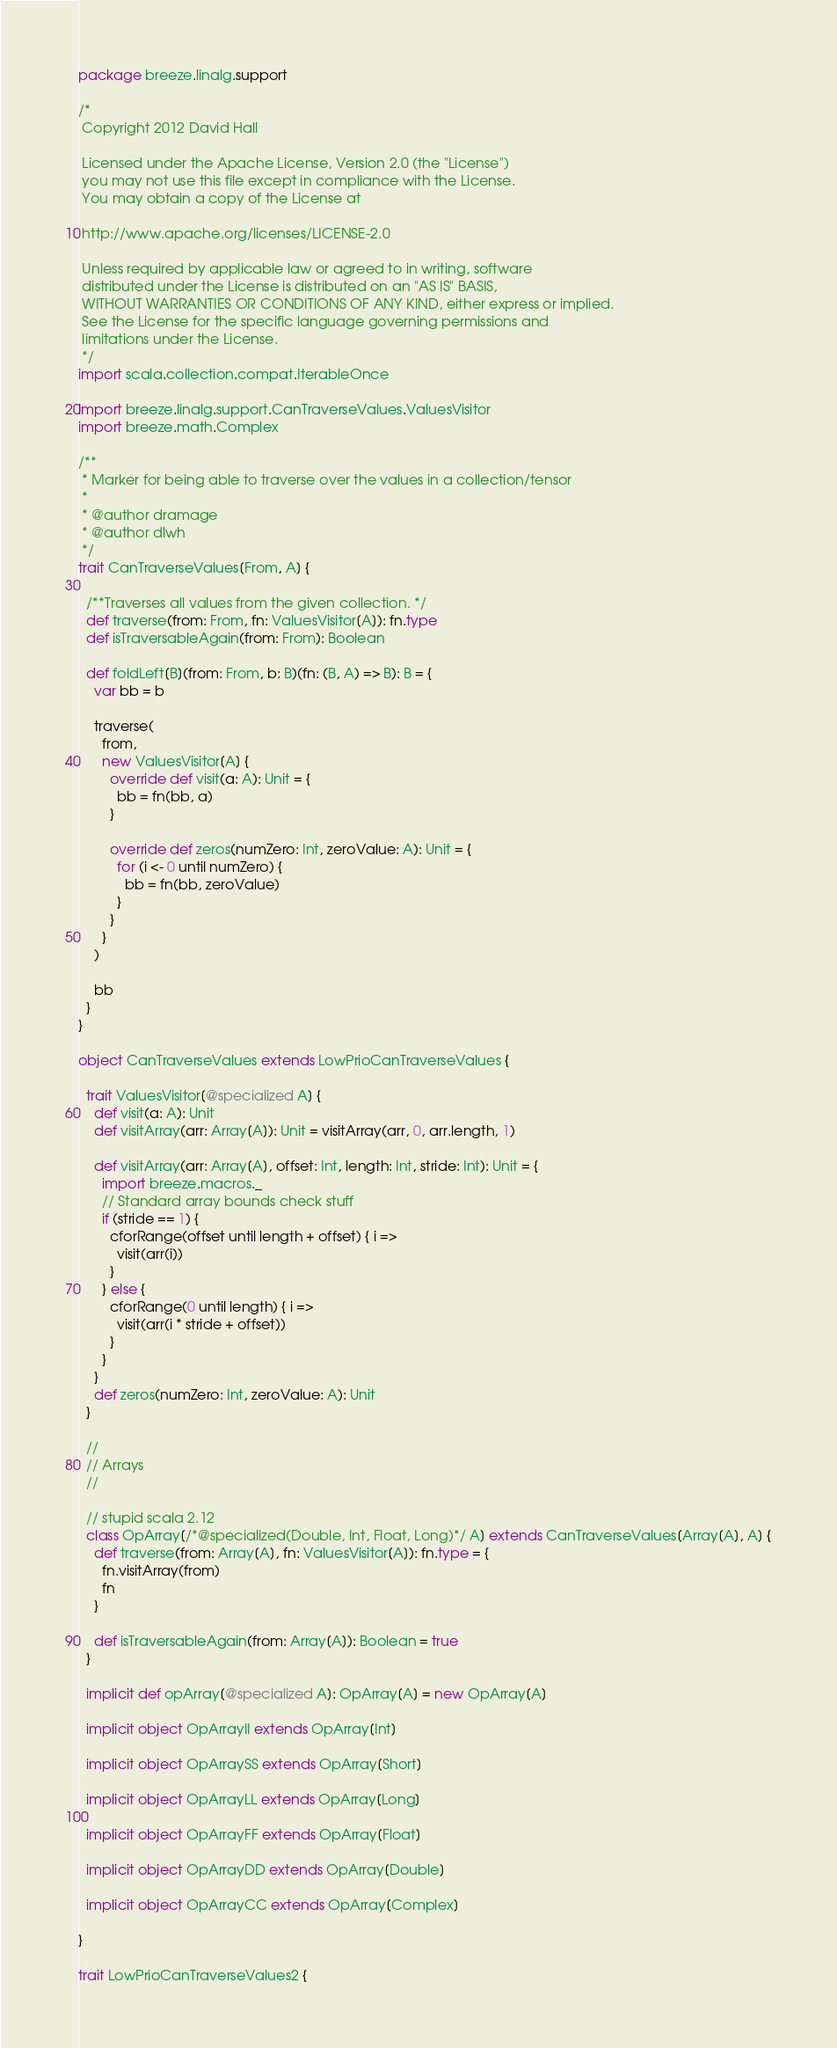Convert code to text. <code><loc_0><loc_0><loc_500><loc_500><_Scala_>package breeze.linalg.support

/*
 Copyright 2012 David Hall

 Licensed under the Apache License, Version 2.0 (the "License")
 you may not use this file except in compliance with the License.
 You may obtain a copy of the License at

 http://www.apache.org/licenses/LICENSE-2.0

 Unless required by applicable law or agreed to in writing, software
 distributed under the License is distributed on an "AS IS" BASIS,
 WITHOUT WARRANTIES OR CONDITIONS OF ANY KIND, either express or implied.
 See the License for the specific language governing permissions and
 limitations under the License.
 */
import scala.collection.compat.IterableOnce

import breeze.linalg.support.CanTraverseValues.ValuesVisitor
import breeze.math.Complex

/**
 * Marker for being able to traverse over the values in a collection/tensor
 *
 * @author dramage
 * @author dlwh
 */
trait CanTraverseValues[From, A] {

  /**Traverses all values from the given collection. */
  def traverse(from: From, fn: ValuesVisitor[A]): fn.type
  def isTraversableAgain(from: From): Boolean

  def foldLeft[B](from: From, b: B)(fn: (B, A) => B): B = {
    var bb = b

    traverse(
      from,
      new ValuesVisitor[A] {
        override def visit(a: A): Unit = {
          bb = fn(bb, a)
        }

        override def zeros(numZero: Int, zeroValue: A): Unit = {
          for (i <- 0 until numZero) {
            bb = fn(bb, zeroValue)
          }
        }
      }
    )

    bb
  }
}

object CanTraverseValues extends LowPrioCanTraverseValues {

  trait ValuesVisitor[@specialized A] {
    def visit(a: A): Unit
    def visitArray(arr: Array[A]): Unit = visitArray(arr, 0, arr.length, 1)

    def visitArray(arr: Array[A], offset: Int, length: Int, stride: Int): Unit = {
      import breeze.macros._
      // Standard array bounds check stuff
      if (stride == 1) {
        cforRange(offset until length + offset) { i =>
          visit(arr(i))
        }
      } else {
        cforRange(0 until length) { i =>
          visit(arr(i * stride + offset))
        }
      }
    }
    def zeros(numZero: Int, zeroValue: A): Unit
  }

  //
  // Arrays
  //

  // stupid scala 2.12
  class OpArray[/*@specialized(Double, Int, Float, Long)*/ A] extends CanTraverseValues[Array[A], A] {
    def traverse(from: Array[A], fn: ValuesVisitor[A]): fn.type = {
      fn.visitArray(from)
      fn
    }

    def isTraversableAgain(from: Array[A]): Boolean = true
  }

  implicit def opArray[@specialized A]: OpArray[A] = new OpArray[A]

  implicit object OpArrayII extends OpArray[Int]

  implicit object OpArraySS extends OpArray[Short]

  implicit object OpArrayLL extends OpArray[Long]

  implicit object OpArrayFF extends OpArray[Float]

  implicit object OpArrayDD extends OpArray[Double]

  implicit object OpArrayCC extends OpArray[Complex]

}

trait LowPrioCanTraverseValues2 {</code> 